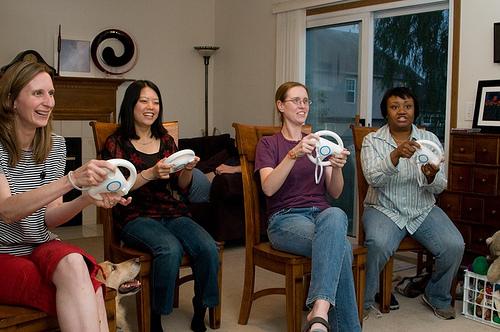How many people are playing the Wii?
Short answer required. 4. How many people are reading books?
Give a very brief answer. 0. Is there a child in the background?
Concise answer only. No. Are there any seats available?
Short answer required. No. Are these people the same age?
Be succinct. Yes. What sport do these girls play?
Give a very brief answer. Wii. What do the women have in their hands?
Answer briefly. Controllers. What is the man sitting on?
Be succinct. Chair. What is the man standing holding in his hand?
Be succinct. No man. What are the women holding in their hands?
Write a very short answer. Wii controllers. What gaming system are the woman playing?
Keep it brief. Wii. Are the people in Japan?
Be succinct. No. What are the women holding?
Be succinct. Game controllers. 